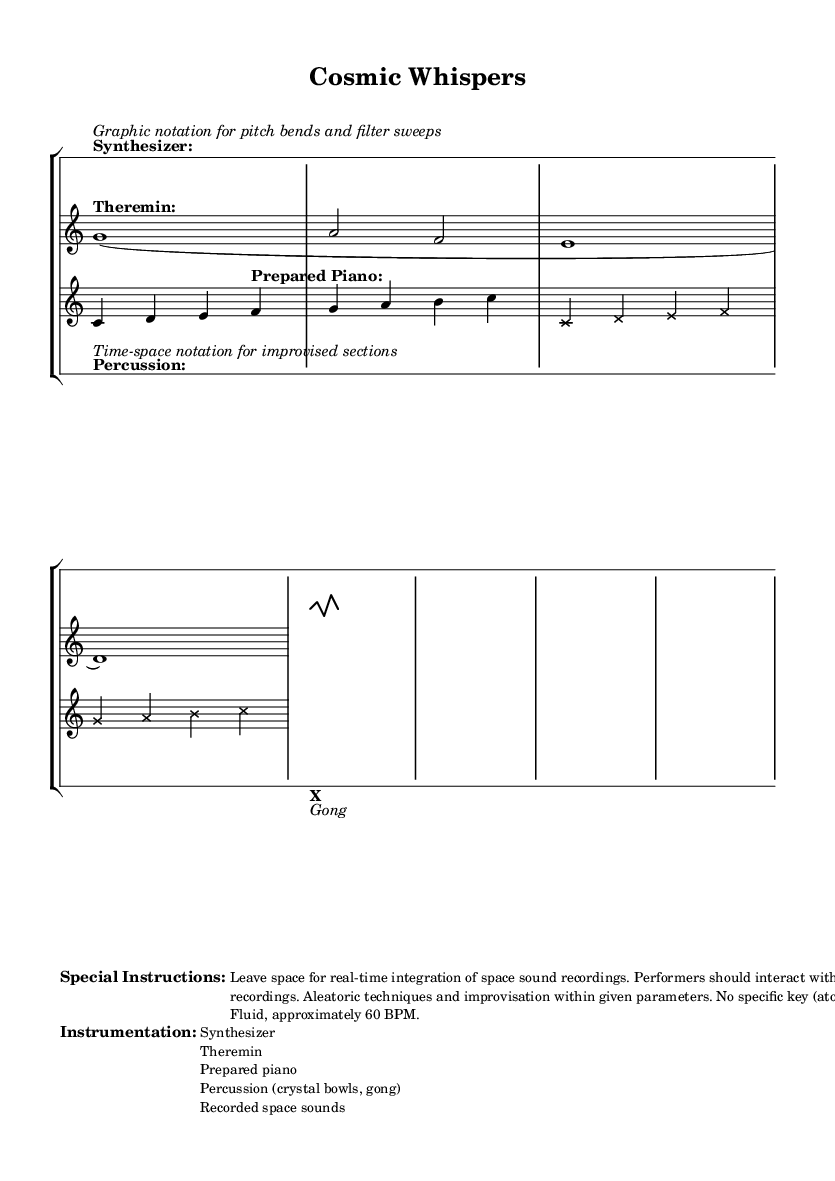What is the time signature of the piece? The time signature is 4/4, as indicated by the notation present at the beginning of each staff.
Answer: 4/4 What instruments are used in this composition? The composition features a synthesizer, theremin, prepared piano, percussion (crystal bowls, gong), and recorded space sounds, all listed under "Instrumentation."
Answer: Synthesizer, theremin, prepared piano, percussion, recorded space sounds What is the tempo marking indicated in the instructions? The tempo is described as "Fluid, approximately 60 BPM," which is found in the "Special Instructions" section.
Answer: Fluid, approximately 60 BPM What type of notation is used for the synthesizer part? The synthesizer part employs graphic notation, shown in the markup accompanying the synthesizer staff and detailing pitch bends and filter sweeps.
Answer: Graphic notation What performance techniques are suggested for the musicians? Musicians are instructed to interact with space recordings and utilize aleatoric techniques and improvisation within given parameters, as outlined in the special instructions.
Answer: Interaction, aleatoric techniques, improvisation How many staves are there in total? There are four staves in total: one each for synthesizer, theremin, and prepared piano, along with one drum staff for percussion.
Answer: Four 